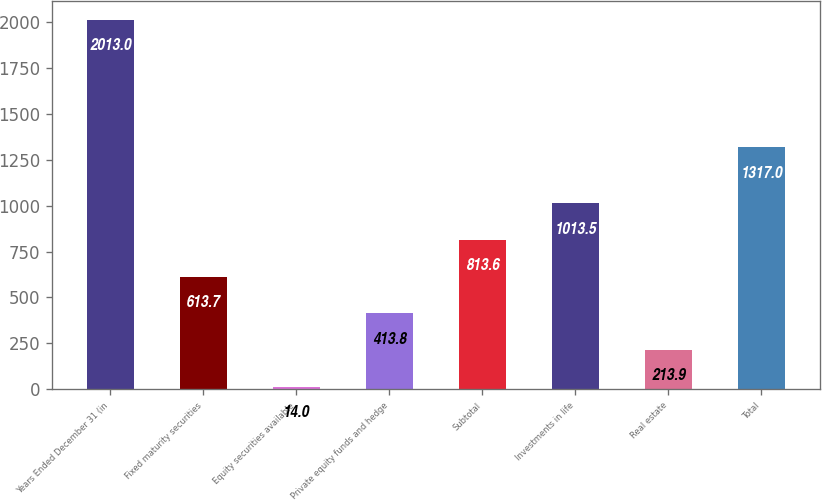Convert chart. <chart><loc_0><loc_0><loc_500><loc_500><bar_chart><fcel>Years Ended December 31 (in<fcel>Fixed maturity securities<fcel>Equity securities available<fcel>Private equity funds and hedge<fcel>Subtotal<fcel>Investments in life<fcel>Real estate<fcel>Total<nl><fcel>2013<fcel>613.7<fcel>14<fcel>413.8<fcel>813.6<fcel>1013.5<fcel>213.9<fcel>1317<nl></chart> 